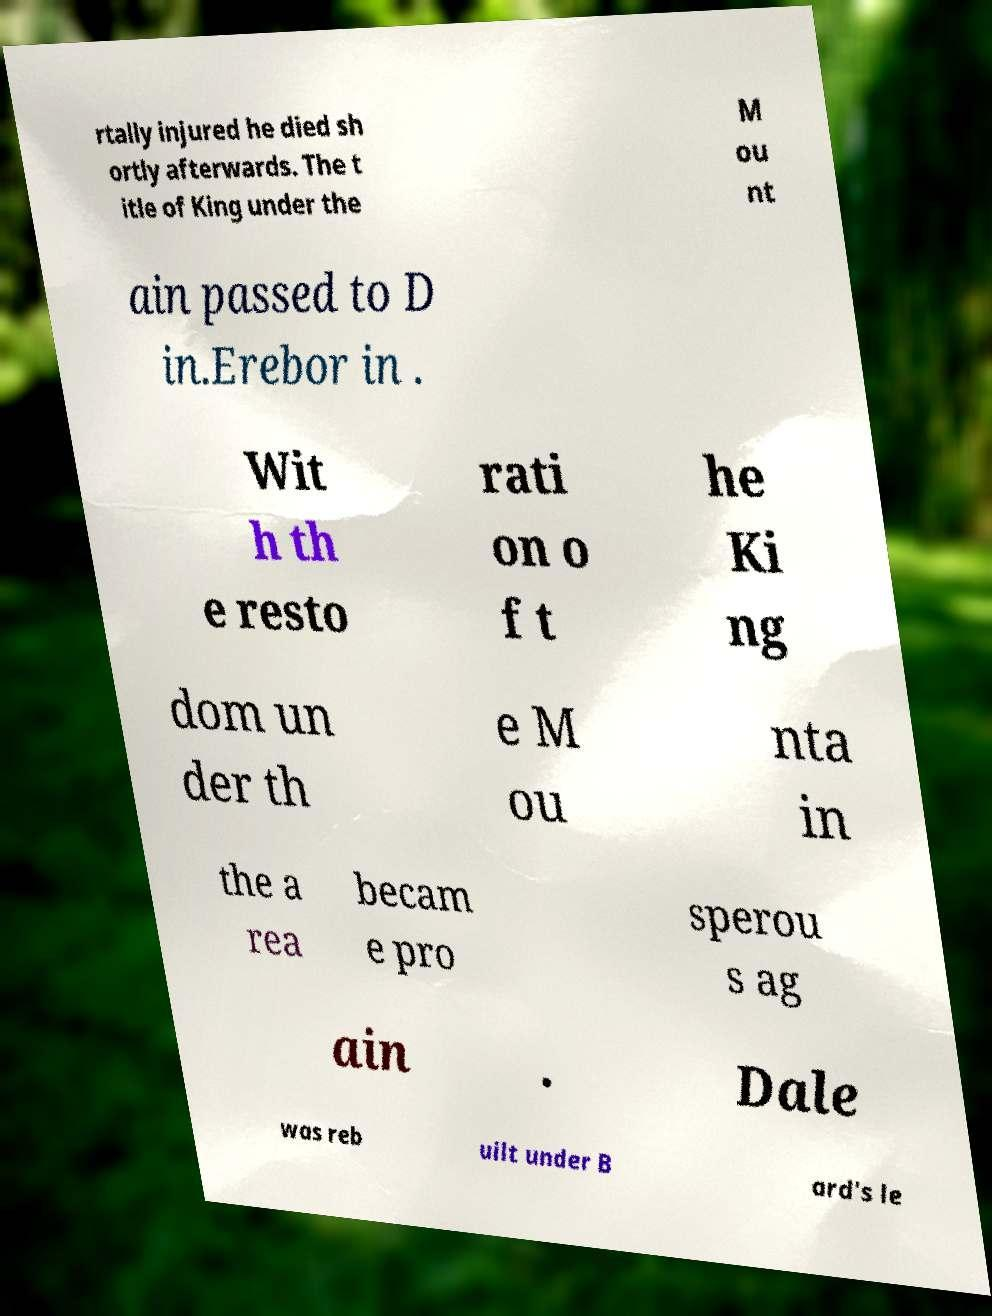Please identify and transcribe the text found in this image. rtally injured he died sh ortly afterwards. The t itle of King under the M ou nt ain passed to D in.Erebor in . Wit h th e resto rati on o f t he Ki ng dom un der th e M ou nta in the a rea becam e pro sperou s ag ain . Dale was reb uilt under B ard's le 